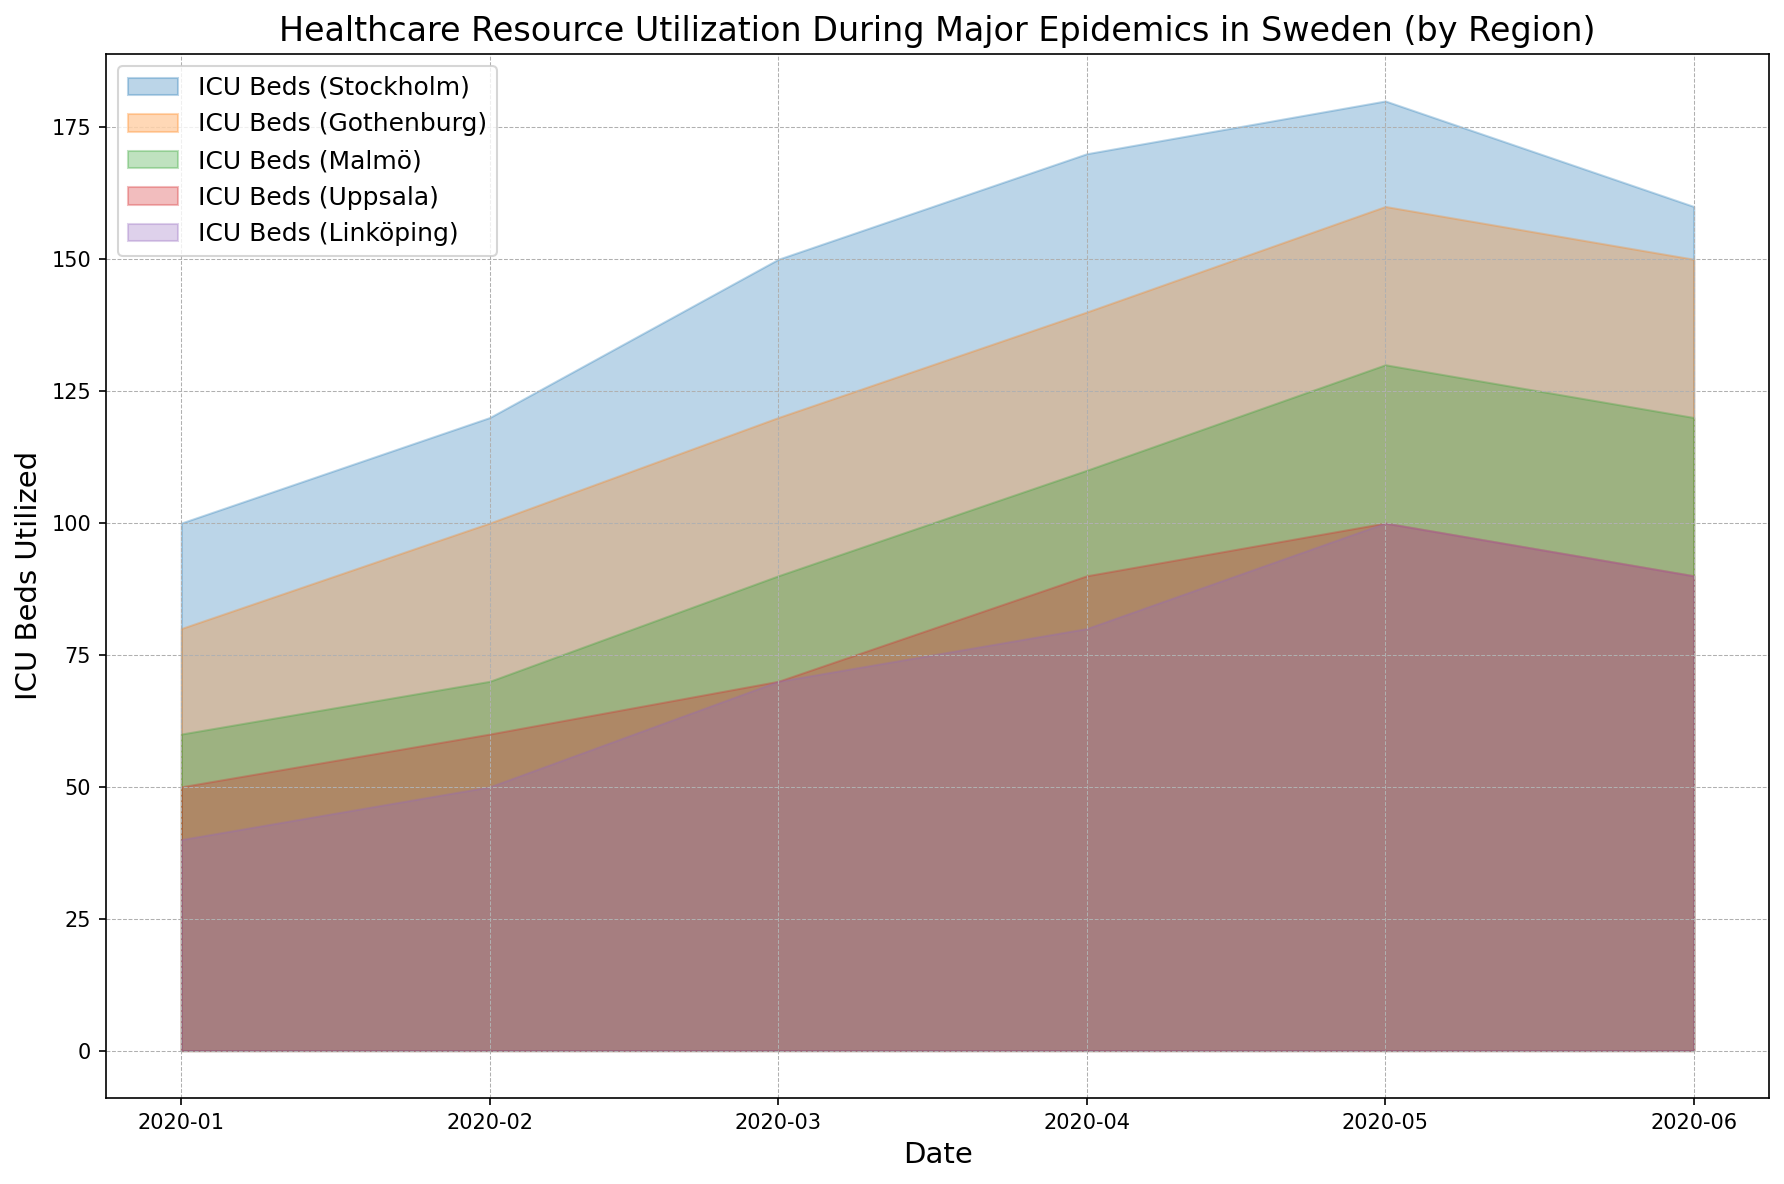What trend can be observed for ICU Bed utilization in the Stockholm region from January to June 2020? The ICU Bed usage in Stockholm shows a steady increase from January (100) to May (180), followed by a slight decrease in June (160).
Answer: Steady increase then slight decrease Which region had the highest ICU Bed utilization in March 2020? By observing the height of the area chart in March, Stockholm had the highest ICU Bed utilization with 150 beds compared to other regions.
Answer: Stockholm How does the ICU Bed utilization in Malmö for April 2020 compare to that in Linköping for the same month? In April 2020, Malmö had 110 ICU Beds utilized, whereas Linköping had 80 ICU Beds utilized. This shows that Malmö had a higher utilization than Linköping in April.
Answer: Malmö had higher utilization What's the total ICU Bed utilization for all regions combined in April 2020? Summing the ICU Beds for each region in April 2020: Stockholm (170) + Gothenburg (140) + Malmö (110) + Uppsala (90) + Linköping (80) amounts to 590.
Answer: 590 By observing the area chart, which region showed a noticeable decline in ICU Bed utilization between May and June 2020? Linköping showed a noticeable decline in ICU Bed utilization from 100 in May to 90 in June, indicating a decrease.
Answer: Linköping Which region had the most stable ICU Bed utilization throughout the period from January to June 2020? Observing the different curves: Uppsala had the most stable ICU Bed utilization, with values ranging only from 50 to 100.
Answer: Uppsala Compare the ICU Bed utilization trends of Gothenburg and Malmö. Which region generally had higher utilization? By comparing the areas for both regions, Gothenburg consistently had higher ICU Bed utilization than Malmö throughout January to June 2020.
Answer: Gothenburg What is the average ICU Bed utilization in Stockholm from January to June 2020? Sum the ICU Beds from January to June for Stockholm (100 + 120 + 150 + 170 + 180 + 160) to get 880, then divide by 6 months to get the average: 880/6 ≈ 146.67.
Answer: 146.67 Which region showed the largest increase in ICU Bed utilization from January to February 2020? By looking at the changes between January and February, Stockholm increased from 100 to 120, Gothenburg from 80 to 100, Malmö from 60 to 70, Uppsala from 50 to 60, and Linköping from 40 to 50. Each increase is 20 beds, which is the largest increase among the regions.
Answer: All regions had an equal increase 